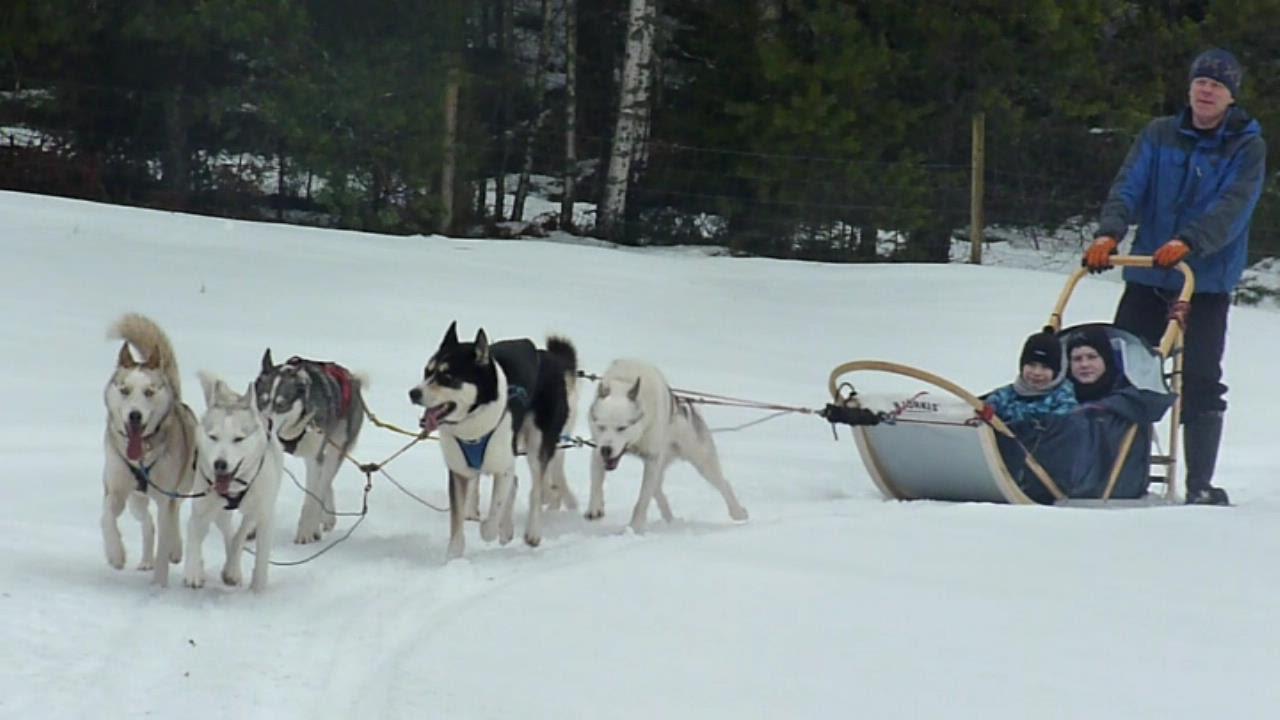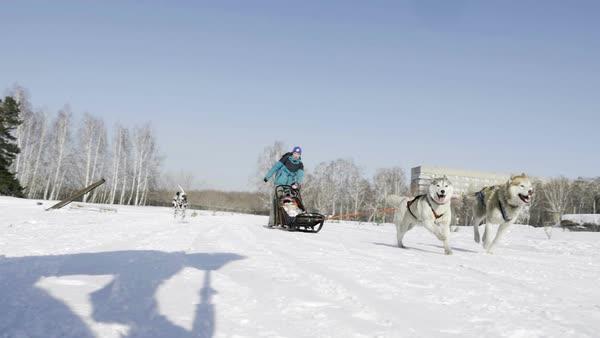The first image is the image on the left, the second image is the image on the right. Examine the images to the left and right. Is the description "Two light colored dogs are pulling a sled in one of the images." accurate? Answer yes or no. Yes. The first image is the image on the left, the second image is the image on the right. Examine the images to the left and right. Is the description "There are at least two people sitting down riding a sled." accurate? Answer yes or no. Yes. 